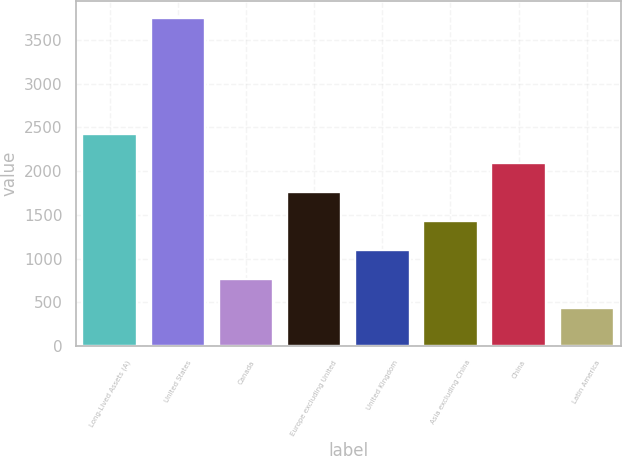Convert chart. <chart><loc_0><loc_0><loc_500><loc_500><bar_chart><fcel>Long-Lived Assets (A)<fcel>United States<fcel>Canada<fcel>Europe excluding United<fcel>United Kingdom<fcel>Asia excluding China<fcel>China<fcel>Latin America<nl><fcel>2429.64<fcel>3756<fcel>771.69<fcel>1766.46<fcel>1103.28<fcel>1434.87<fcel>2098.05<fcel>440.1<nl></chart> 